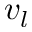Convert formula to latex. <formula><loc_0><loc_0><loc_500><loc_500>v _ { l }</formula> 